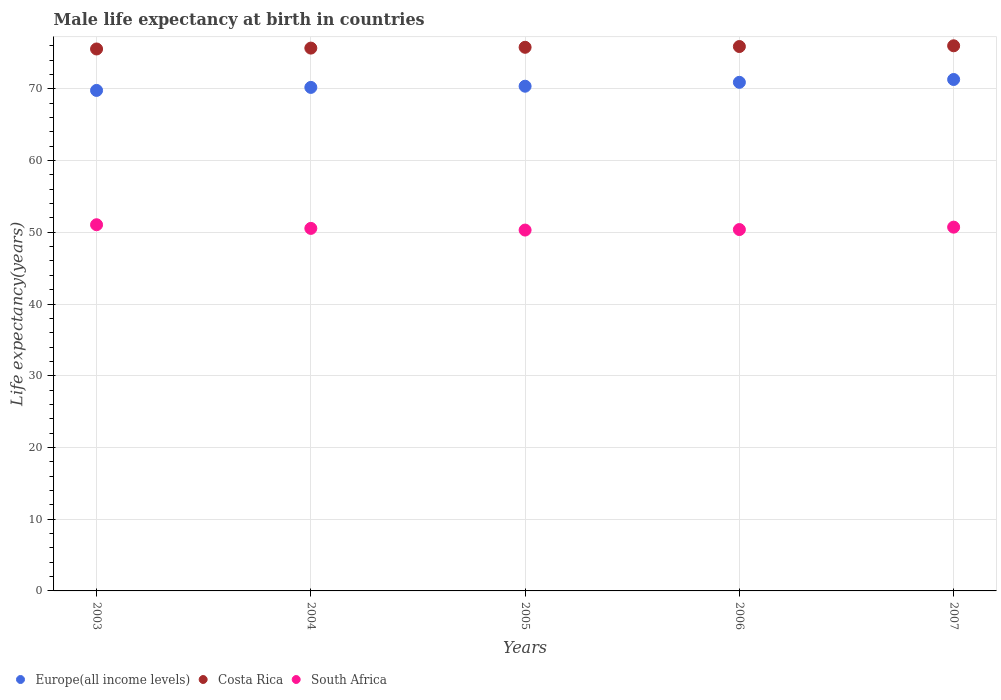How many different coloured dotlines are there?
Keep it short and to the point. 3. Is the number of dotlines equal to the number of legend labels?
Give a very brief answer. Yes. What is the male life expectancy at birth in Europe(all income levels) in 2004?
Provide a short and direct response. 70.2. Across all years, what is the maximum male life expectancy at birth in Europe(all income levels)?
Keep it short and to the point. 71.3. Across all years, what is the minimum male life expectancy at birth in South Africa?
Offer a terse response. 50.31. In which year was the male life expectancy at birth in Costa Rica maximum?
Give a very brief answer. 2007. What is the total male life expectancy at birth in South Africa in the graph?
Provide a succinct answer. 253.01. What is the difference between the male life expectancy at birth in Costa Rica in 2006 and that in 2007?
Offer a terse response. -0.1. What is the difference between the male life expectancy at birth in Costa Rica in 2004 and the male life expectancy at birth in Europe(all income levels) in 2007?
Make the answer very short. 4.38. What is the average male life expectancy at birth in South Africa per year?
Provide a short and direct response. 50.6. In the year 2005, what is the difference between the male life expectancy at birth in Costa Rica and male life expectancy at birth in Europe(all income levels)?
Your response must be concise. 5.43. In how many years, is the male life expectancy at birth in South Africa greater than 2 years?
Ensure brevity in your answer.  5. What is the ratio of the male life expectancy at birth in Costa Rica in 2004 to that in 2005?
Provide a succinct answer. 1. Is the male life expectancy at birth in Europe(all income levels) in 2003 less than that in 2007?
Keep it short and to the point. Yes. What is the difference between the highest and the second highest male life expectancy at birth in South Africa?
Give a very brief answer. 0.34. What is the difference between the highest and the lowest male life expectancy at birth in Costa Rica?
Give a very brief answer. 0.44. Is the sum of the male life expectancy at birth in Europe(all income levels) in 2005 and 2007 greater than the maximum male life expectancy at birth in Costa Rica across all years?
Ensure brevity in your answer.  Yes. Is it the case that in every year, the sum of the male life expectancy at birth in Europe(all income levels) and male life expectancy at birth in South Africa  is greater than the male life expectancy at birth in Costa Rica?
Make the answer very short. Yes. Does the male life expectancy at birth in South Africa monotonically increase over the years?
Your answer should be very brief. No. Is the male life expectancy at birth in Europe(all income levels) strictly greater than the male life expectancy at birth in Costa Rica over the years?
Keep it short and to the point. No. How many years are there in the graph?
Give a very brief answer. 5. What is the difference between two consecutive major ticks on the Y-axis?
Your answer should be very brief. 10. Are the values on the major ticks of Y-axis written in scientific E-notation?
Give a very brief answer. No. Does the graph contain any zero values?
Your answer should be very brief. No. How many legend labels are there?
Your response must be concise. 3. What is the title of the graph?
Offer a terse response. Male life expectancy at birth in countries. What is the label or title of the X-axis?
Give a very brief answer. Years. What is the label or title of the Y-axis?
Keep it short and to the point. Life expectancy(years). What is the Life expectancy(years) of Europe(all income levels) in 2003?
Give a very brief answer. 69.78. What is the Life expectancy(years) of Costa Rica in 2003?
Provide a succinct answer. 75.56. What is the Life expectancy(years) in South Africa in 2003?
Your response must be concise. 51.05. What is the Life expectancy(years) in Europe(all income levels) in 2004?
Make the answer very short. 70.2. What is the Life expectancy(years) in Costa Rica in 2004?
Your answer should be very brief. 75.68. What is the Life expectancy(years) of South Africa in 2004?
Offer a terse response. 50.54. What is the Life expectancy(years) of Europe(all income levels) in 2005?
Make the answer very short. 70.37. What is the Life expectancy(years) in Costa Rica in 2005?
Make the answer very short. 75.79. What is the Life expectancy(years) in South Africa in 2005?
Give a very brief answer. 50.31. What is the Life expectancy(years) of Europe(all income levels) in 2006?
Provide a succinct answer. 70.91. What is the Life expectancy(years) in Costa Rica in 2006?
Your answer should be compact. 75.9. What is the Life expectancy(years) in South Africa in 2006?
Your answer should be very brief. 50.38. What is the Life expectancy(years) of Europe(all income levels) in 2007?
Keep it short and to the point. 71.3. What is the Life expectancy(years) in Costa Rica in 2007?
Make the answer very short. 76. What is the Life expectancy(years) of South Africa in 2007?
Your response must be concise. 50.72. Across all years, what is the maximum Life expectancy(years) of Europe(all income levels)?
Your response must be concise. 71.3. Across all years, what is the maximum Life expectancy(years) in Costa Rica?
Ensure brevity in your answer.  76. Across all years, what is the maximum Life expectancy(years) of South Africa?
Your response must be concise. 51.05. Across all years, what is the minimum Life expectancy(years) in Europe(all income levels)?
Your answer should be very brief. 69.78. Across all years, what is the minimum Life expectancy(years) in Costa Rica?
Offer a terse response. 75.56. Across all years, what is the minimum Life expectancy(years) in South Africa?
Give a very brief answer. 50.31. What is the total Life expectancy(years) of Europe(all income levels) in the graph?
Make the answer very short. 352.56. What is the total Life expectancy(years) in Costa Rica in the graph?
Provide a short and direct response. 378.94. What is the total Life expectancy(years) in South Africa in the graph?
Provide a short and direct response. 253.01. What is the difference between the Life expectancy(years) in Europe(all income levels) in 2003 and that in 2004?
Your answer should be very brief. -0.42. What is the difference between the Life expectancy(years) of Costa Rica in 2003 and that in 2004?
Provide a succinct answer. -0.12. What is the difference between the Life expectancy(years) of South Africa in 2003 and that in 2004?
Give a very brief answer. 0.51. What is the difference between the Life expectancy(years) in Europe(all income levels) in 2003 and that in 2005?
Give a very brief answer. -0.59. What is the difference between the Life expectancy(years) of Costa Rica in 2003 and that in 2005?
Ensure brevity in your answer.  -0.23. What is the difference between the Life expectancy(years) in South Africa in 2003 and that in 2005?
Ensure brevity in your answer.  0.74. What is the difference between the Life expectancy(years) in Europe(all income levels) in 2003 and that in 2006?
Your response must be concise. -1.13. What is the difference between the Life expectancy(years) of Costa Rica in 2003 and that in 2006?
Keep it short and to the point. -0.34. What is the difference between the Life expectancy(years) in South Africa in 2003 and that in 2006?
Offer a very short reply. 0.67. What is the difference between the Life expectancy(years) of Europe(all income levels) in 2003 and that in 2007?
Your response must be concise. -1.52. What is the difference between the Life expectancy(years) in Costa Rica in 2003 and that in 2007?
Your answer should be compact. -0.44. What is the difference between the Life expectancy(years) of South Africa in 2003 and that in 2007?
Your answer should be compact. 0.34. What is the difference between the Life expectancy(years) of Europe(all income levels) in 2004 and that in 2005?
Keep it short and to the point. -0.17. What is the difference between the Life expectancy(years) in Costa Rica in 2004 and that in 2005?
Offer a very short reply. -0.11. What is the difference between the Life expectancy(years) of South Africa in 2004 and that in 2005?
Your answer should be compact. 0.23. What is the difference between the Life expectancy(years) of Europe(all income levels) in 2004 and that in 2006?
Give a very brief answer. -0.71. What is the difference between the Life expectancy(years) in Costa Rica in 2004 and that in 2006?
Offer a terse response. -0.22. What is the difference between the Life expectancy(years) in South Africa in 2004 and that in 2006?
Your answer should be compact. 0.16. What is the difference between the Life expectancy(years) in Europe(all income levels) in 2004 and that in 2007?
Provide a short and direct response. -1.1. What is the difference between the Life expectancy(years) in Costa Rica in 2004 and that in 2007?
Your response must be concise. -0.32. What is the difference between the Life expectancy(years) in South Africa in 2004 and that in 2007?
Offer a terse response. -0.17. What is the difference between the Life expectancy(years) in Europe(all income levels) in 2005 and that in 2006?
Make the answer very short. -0.54. What is the difference between the Life expectancy(years) in Costa Rica in 2005 and that in 2006?
Ensure brevity in your answer.  -0.11. What is the difference between the Life expectancy(years) in South Africa in 2005 and that in 2006?
Provide a short and direct response. -0.07. What is the difference between the Life expectancy(years) of Europe(all income levels) in 2005 and that in 2007?
Your answer should be very brief. -0.94. What is the difference between the Life expectancy(years) of Costa Rica in 2005 and that in 2007?
Provide a short and direct response. -0.21. What is the difference between the Life expectancy(years) in South Africa in 2005 and that in 2007?
Keep it short and to the point. -0.41. What is the difference between the Life expectancy(years) of Europe(all income levels) in 2006 and that in 2007?
Offer a very short reply. -0.4. What is the difference between the Life expectancy(years) in Costa Rica in 2006 and that in 2007?
Keep it short and to the point. -0.1. What is the difference between the Life expectancy(years) of South Africa in 2006 and that in 2007?
Provide a succinct answer. -0.34. What is the difference between the Life expectancy(years) of Europe(all income levels) in 2003 and the Life expectancy(years) of Costa Rica in 2004?
Your answer should be very brief. -5.9. What is the difference between the Life expectancy(years) in Europe(all income levels) in 2003 and the Life expectancy(years) in South Africa in 2004?
Ensure brevity in your answer.  19.24. What is the difference between the Life expectancy(years) of Costa Rica in 2003 and the Life expectancy(years) of South Africa in 2004?
Make the answer very short. 25.02. What is the difference between the Life expectancy(years) of Europe(all income levels) in 2003 and the Life expectancy(years) of Costa Rica in 2005?
Provide a succinct answer. -6.01. What is the difference between the Life expectancy(years) of Europe(all income levels) in 2003 and the Life expectancy(years) of South Africa in 2005?
Keep it short and to the point. 19.47. What is the difference between the Life expectancy(years) of Costa Rica in 2003 and the Life expectancy(years) of South Africa in 2005?
Offer a terse response. 25.25. What is the difference between the Life expectancy(years) in Europe(all income levels) in 2003 and the Life expectancy(years) in Costa Rica in 2006?
Make the answer very short. -6.12. What is the difference between the Life expectancy(years) in Europe(all income levels) in 2003 and the Life expectancy(years) in South Africa in 2006?
Make the answer very short. 19.4. What is the difference between the Life expectancy(years) in Costa Rica in 2003 and the Life expectancy(years) in South Africa in 2006?
Offer a terse response. 25.18. What is the difference between the Life expectancy(years) in Europe(all income levels) in 2003 and the Life expectancy(years) in Costa Rica in 2007?
Your response must be concise. -6.22. What is the difference between the Life expectancy(years) in Europe(all income levels) in 2003 and the Life expectancy(years) in South Africa in 2007?
Your answer should be compact. 19.06. What is the difference between the Life expectancy(years) of Costa Rica in 2003 and the Life expectancy(years) of South Africa in 2007?
Your answer should be very brief. 24.84. What is the difference between the Life expectancy(years) of Europe(all income levels) in 2004 and the Life expectancy(years) of Costa Rica in 2005?
Provide a succinct answer. -5.59. What is the difference between the Life expectancy(years) in Europe(all income levels) in 2004 and the Life expectancy(years) in South Africa in 2005?
Keep it short and to the point. 19.89. What is the difference between the Life expectancy(years) of Costa Rica in 2004 and the Life expectancy(years) of South Africa in 2005?
Provide a succinct answer. 25.37. What is the difference between the Life expectancy(years) of Europe(all income levels) in 2004 and the Life expectancy(years) of Costa Rica in 2006?
Give a very brief answer. -5.7. What is the difference between the Life expectancy(years) of Europe(all income levels) in 2004 and the Life expectancy(years) of South Africa in 2006?
Your answer should be compact. 19.82. What is the difference between the Life expectancy(years) of Costa Rica in 2004 and the Life expectancy(years) of South Africa in 2006?
Your answer should be compact. 25.3. What is the difference between the Life expectancy(years) of Europe(all income levels) in 2004 and the Life expectancy(years) of Costa Rica in 2007?
Offer a very short reply. -5.8. What is the difference between the Life expectancy(years) in Europe(all income levels) in 2004 and the Life expectancy(years) in South Africa in 2007?
Ensure brevity in your answer.  19.48. What is the difference between the Life expectancy(years) of Costa Rica in 2004 and the Life expectancy(years) of South Africa in 2007?
Your answer should be very brief. 24.96. What is the difference between the Life expectancy(years) in Europe(all income levels) in 2005 and the Life expectancy(years) in Costa Rica in 2006?
Provide a succinct answer. -5.53. What is the difference between the Life expectancy(years) of Europe(all income levels) in 2005 and the Life expectancy(years) of South Africa in 2006?
Provide a short and direct response. 19.99. What is the difference between the Life expectancy(years) in Costa Rica in 2005 and the Life expectancy(years) in South Africa in 2006?
Your answer should be very brief. 25.41. What is the difference between the Life expectancy(years) of Europe(all income levels) in 2005 and the Life expectancy(years) of Costa Rica in 2007?
Keep it short and to the point. -5.64. What is the difference between the Life expectancy(years) in Europe(all income levels) in 2005 and the Life expectancy(years) in South Africa in 2007?
Provide a succinct answer. 19.65. What is the difference between the Life expectancy(years) in Costa Rica in 2005 and the Life expectancy(years) in South Africa in 2007?
Your response must be concise. 25.08. What is the difference between the Life expectancy(years) in Europe(all income levels) in 2006 and the Life expectancy(years) in Costa Rica in 2007?
Your answer should be compact. -5.09. What is the difference between the Life expectancy(years) in Europe(all income levels) in 2006 and the Life expectancy(years) in South Africa in 2007?
Give a very brief answer. 20.19. What is the difference between the Life expectancy(years) in Costa Rica in 2006 and the Life expectancy(years) in South Africa in 2007?
Offer a very short reply. 25.18. What is the average Life expectancy(years) in Europe(all income levels) per year?
Give a very brief answer. 70.51. What is the average Life expectancy(years) in Costa Rica per year?
Keep it short and to the point. 75.79. What is the average Life expectancy(years) of South Africa per year?
Ensure brevity in your answer.  50.6. In the year 2003, what is the difference between the Life expectancy(years) of Europe(all income levels) and Life expectancy(years) of Costa Rica?
Your answer should be compact. -5.78. In the year 2003, what is the difference between the Life expectancy(years) of Europe(all income levels) and Life expectancy(years) of South Africa?
Your response must be concise. 18.73. In the year 2003, what is the difference between the Life expectancy(years) of Costa Rica and Life expectancy(years) of South Africa?
Your answer should be compact. 24.5. In the year 2004, what is the difference between the Life expectancy(years) of Europe(all income levels) and Life expectancy(years) of Costa Rica?
Your answer should be very brief. -5.48. In the year 2004, what is the difference between the Life expectancy(years) in Europe(all income levels) and Life expectancy(years) in South Africa?
Provide a succinct answer. 19.66. In the year 2004, what is the difference between the Life expectancy(years) of Costa Rica and Life expectancy(years) of South Africa?
Keep it short and to the point. 25.14. In the year 2005, what is the difference between the Life expectancy(years) in Europe(all income levels) and Life expectancy(years) in Costa Rica?
Give a very brief answer. -5.43. In the year 2005, what is the difference between the Life expectancy(years) of Europe(all income levels) and Life expectancy(years) of South Africa?
Ensure brevity in your answer.  20.06. In the year 2005, what is the difference between the Life expectancy(years) in Costa Rica and Life expectancy(years) in South Africa?
Your response must be concise. 25.48. In the year 2006, what is the difference between the Life expectancy(years) of Europe(all income levels) and Life expectancy(years) of Costa Rica?
Offer a very short reply. -4.99. In the year 2006, what is the difference between the Life expectancy(years) in Europe(all income levels) and Life expectancy(years) in South Africa?
Provide a short and direct response. 20.53. In the year 2006, what is the difference between the Life expectancy(years) in Costa Rica and Life expectancy(years) in South Africa?
Make the answer very short. 25.52. In the year 2007, what is the difference between the Life expectancy(years) in Europe(all income levels) and Life expectancy(years) in Costa Rica?
Your response must be concise. -4.7. In the year 2007, what is the difference between the Life expectancy(years) of Europe(all income levels) and Life expectancy(years) of South Africa?
Make the answer very short. 20.59. In the year 2007, what is the difference between the Life expectancy(years) in Costa Rica and Life expectancy(years) in South Africa?
Offer a terse response. 25.29. What is the ratio of the Life expectancy(years) of Europe(all income levels) in 2003 to that in 2004?
Provide a succinct answer. 0.99. What is the ratio of the Life expectancy(years) in Costa Rica in 2003 to that in 2004?
Your answer should be very brief. 1. What is the ratio of the Life expectancy(years) in South Africa in 2003 to that in 2004?
Ensure brevity in your answer.  1.01. What is the ratio of the Life expectancy(years) of Europe(all income levels) in 2003 to that in 2005?
Ensure brevity in your answer.  0.99. What is the ratio of the Life expectancy(years) in Costa Rica in 2003 to that in 2005?
Your answer should be compact. 1. What is the ratio of the Life expectancy(years) of South Africa in 2003 to that in 2005?
Make the answer very short. 1.01. What is the ratio of the Life expectancy(years) in Europe(all income levels) in 2003 to that in 2006?
Your answer should be compact. 0.98. What is the ratio of the Life expectancy(years) in South Africa in 2003 to that in 2006?
Offer a very short reply. 1.01. What is the ratio of the Life expectancy(years) of Europe(all income levels) in 2003 to that in 2007?
Your answer should be very brief. 0.98. What is the ratio of the Life expectancy(years) of South Africa in 2003 to that in 2007?
Make the answer very short. 1.01. What is the ratio of the Life expectancy(years) of Europe(all income levels) in 2004 to that in 2005?
Your response must be concise. 1. What is the ratio of the Life expectancy(years) of Costa Rica in 2004 to that in 2005?
Provide a succinct answer. 1. What is the ratio of the Life expectancy(years) in South Africa in 2004 to that in 2005?
Provide a succinct answer. 1. What is the ratio of the Life expectancy(years) of Europe(all income levels) in 2004 to that in 2006?
Provide a succinct answer. 0.99. What is the ratio of the Life expectancy(years) of Europe(all income levels) in 2004 to that in 2007?
Offer a terse response. 0.98. What is the ratio of the Life expectancy(years) of Costa Rica in 2005 to that in 2006?
Offer a terse response. 1. What is the ratio of the Life expectancy(years) of Europe(all income levels) in 2005 to that in 2007?
Your answer should be very brief. 0.99. What is the ratio of the Life expectancy(years) in South Africa in 2005 to that in 2007?
Your answer should be compact. 0.99. What is the ratio of the Life expectancy(years) of Costa Rica in 2006 to that in 2007?
Offer a terse response. 1. What is the difference between the highest and the second highest Life expectancy(years) of Europe(all income levels)?
Keep it short and to the point. 0.4. What is the difference between the highest and the second highest Life expectancy(years) of Costa Rica?
Make the answer very short. 0.1. What is the difference between the highest and the second highest Life expectancy(years) in South Africa?
Make the answer very short. 0.34. What is the difference between the highest and the lowest Life expectancy(years) in Europe(all income levels)?
Offer a very short reply. 1.52. What is the difference between the highest and the lowest Life expectancy(years) of Costa Rica?
Your answer should be compact. 0.44. What is the difference between the highest and the lowest Life expectancy(years) in South Africa?
Make the answer very short. 0.74. 